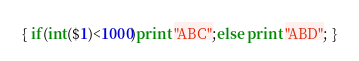Convert code to text. <code><loc_0><loc_0><loc_500><loc_500><_Awk_>{ if(int($1)<1000)print "ABC";else print "ABD"; }</code> 